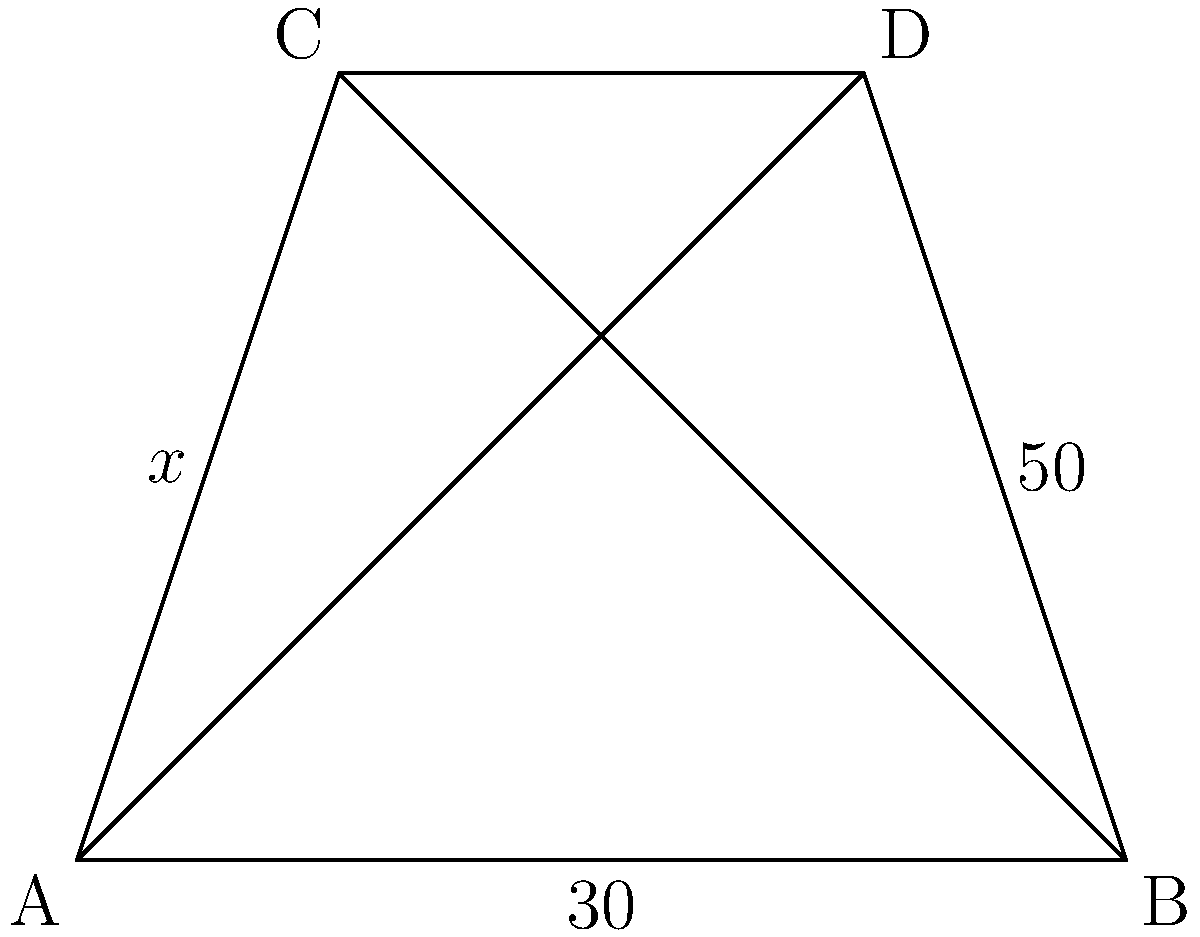In this composition reminiscent of a Dutch angle shot, two intersecting lines form a quadrilateral ABCD. If the angles marked are as shown, what is the value of $x$? Let's approach this step-by-step, thinking about the geometry of the shot composition:

1) In a quadrilateral, the sum of all interior angles is always 360°.

2) We're given two angles: 30° and 50°. Let's call the unmarked angle at B as $y°$.

3) We can write an equation based on the sum of angles in a quadrilateral:
   $x° + 30° + 50° + y° = 360°$

4) The two intersecting lines form two pairs of vertical angles. Vertical angles are always equal. Therefore, $x° = y°$.

5) We can substitute $y$ with $x$ in our equation:
   $x° + 30° + 50° + x° = 360°$

6) Simplify:
   $2x° + 80° = 360°$

7) Subtract 80° from both sides:
   $2x° = 280°$

8) Divide both sides by 2:
   $x° = 140°$

Thus, the value of $x$ is 140°.
Answer: 140° 